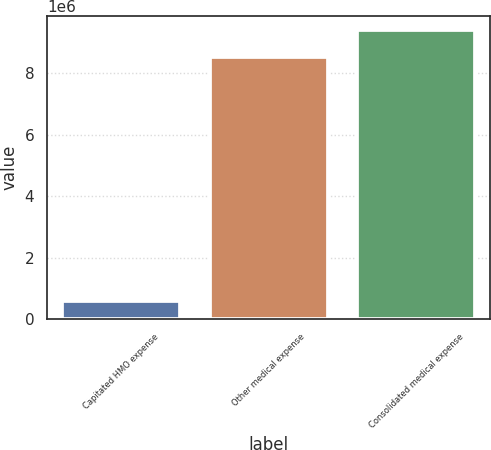Convert chart to OTSL. <chart><loc_0><loc_0><loc_500><loc_500><bar_chart><fcel>Capitated HMO expense<fcel>Other medical expense<fcel>Consolidated medical expense<nl><fcel>603617<fcel>8.53458e+06<fcel>9.38804e+06<nl></chart> 